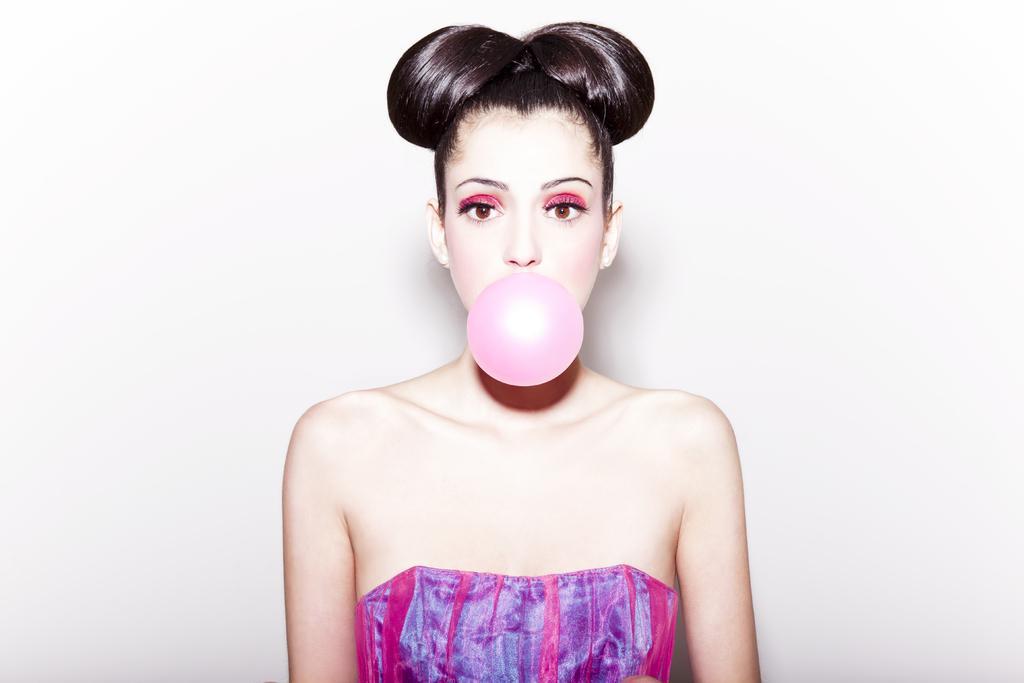Can you describe this image briefly? In this image, we can see a woman is seeing. Here we can see a bubble. Background there is a white wall. 